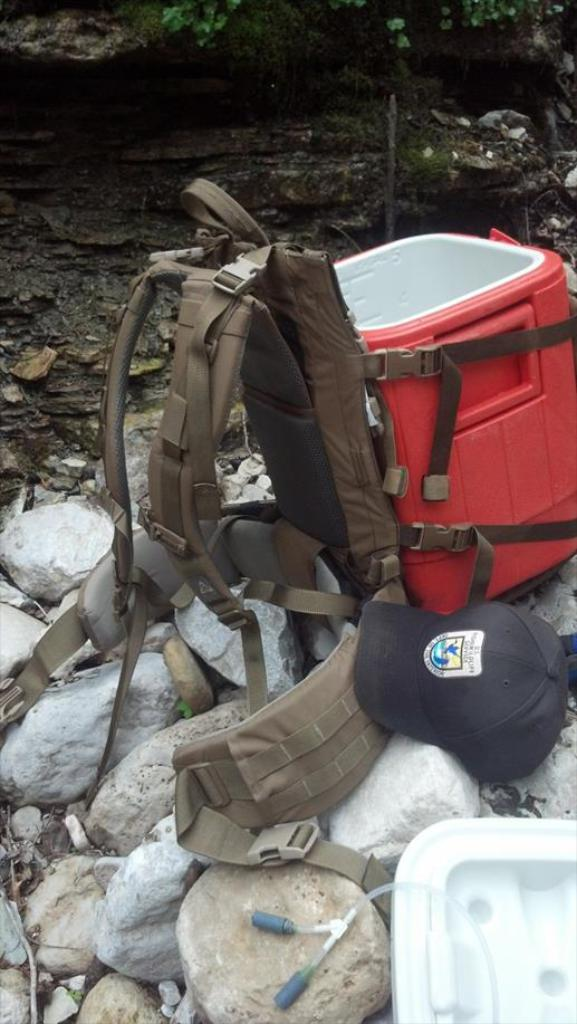What object can be seen in the image that might be used for carrying items? There is a bag in the image that might be used for carrying items. What color is the box that is visible in the image? There is a red box in the image. What type of headwear is present in the image? There is a cap in the image. What type of natural material is present in the image? There are stones in the image. Can you tell me how many monkeys are sitting on the red box in the image? There are no monkeys present in the image; it only features a bag, a red box, a cap, and stones. What type of vase can be seen in the image? There is no vase present in the image. 